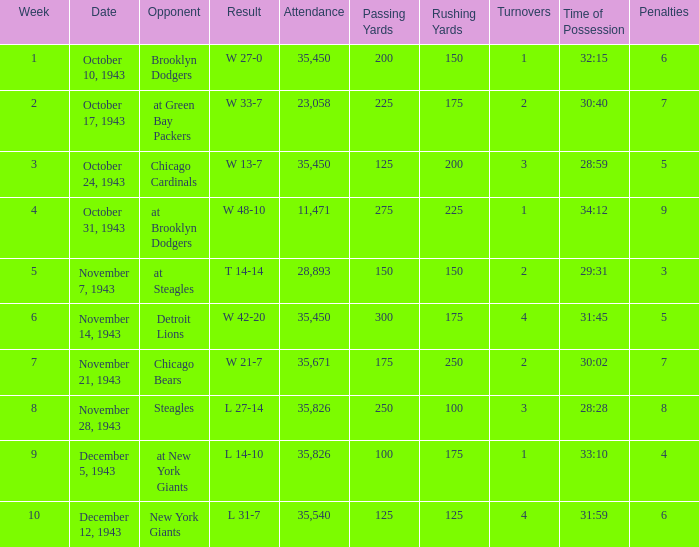How many attendances have 9 as the week? 1.0. 